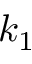Convert formula to latex. <formula><loc_0><loc_0><loc_500><loc_500>k _ { 1 }</formula> 